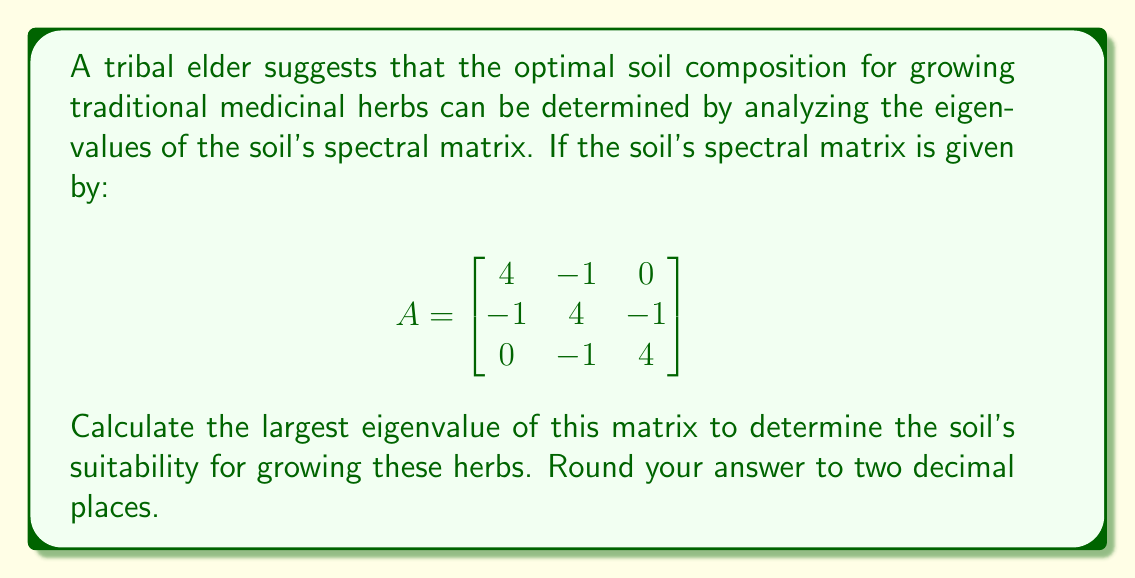Teach me how to tackle this problem. To find the eigenvalues of matrix A, we need to solve the characteristic equation:

1) First, we set up the equation $\det(A - \lambda I) = 0$, where $\lambda$ represents the eigenvalues:

   $$\det\begin{pmatrix}
   4-\lambda & -1 & 0 \\
   -1 & 4-\lambda & -1 \\
   0 & -1 & 4-\lambda
   \end{pmatrix} = 0$$

2) Expanding this determinant:
   $$(4-\lambda)[(4-\lambda)(4-\lambda) - 1] - (-1)[(-1)(4-\lambda) - 0] = 0$$

3) Simplifying:
   $$(4-\lambda)[(4-\lambda)^2 - 1] + (4-\lambda) = 0$$
   $$(4-\lambda)[(4-\lambda)^2 - 1 + 1] = 0$$
   $$(4-\lambda)(4-\lambda)^2 = 0$$

4) Factoring:
   $(4-\lambda)(\lambda^2 - 8\lambda + 15) = 0$

5) Solving this equation:
   $\lambda = 4$ or $\lambda^2 - 8\lambda + 15 = 0$

6) Using the quadratic formula for the second part:
   $\lambda = \frac{8 \pm \sqrt{64 - 60}}{2} = \frac{8 \pm 2}{2}$

7) This gives us all three eigenvalues:
   $\lambda_1 = 4, \lambda_2 = 5, \lambda_3 = 3$

8) The largest eigenvalue is 5.
Answer: 5.00 